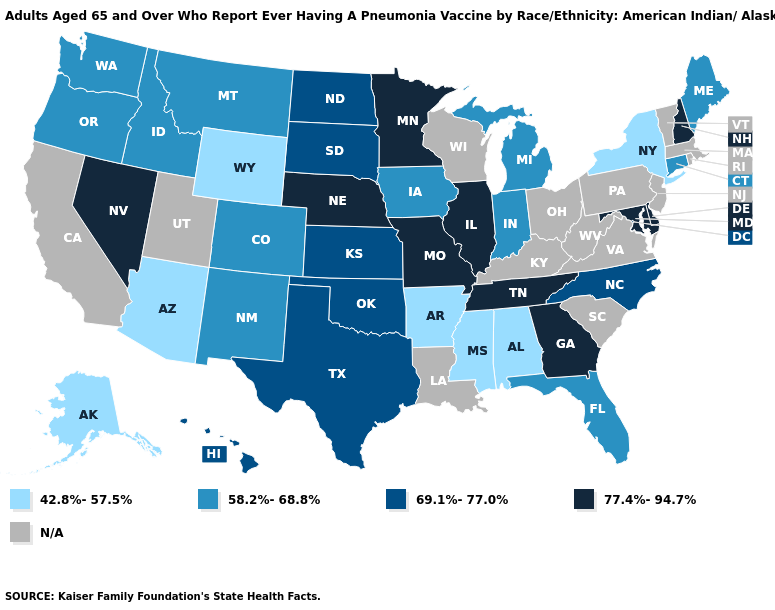Name the states that have a value in the range N/A?
Be succinct. California, Kentucky, Louisiana, Massachusetts, New Jersey, Ohio, Pennsylvania, Rhode Island, South Carolina, Utah, Vermont, Virginia, West Virginia, Wisconsin. What is the lowest value in the West?
Be succinct. 42.8%-57.5%. What is the value of California?
Quick response, please. N/A. Name the states that have a value in the range 42.8%-57.5%?
Quick response, please. Alabama, Alaska, Arizona, Arkansas, Mississippi, New York, Wyoming. Does Arizona have the lowest value in the USA?
Write a very short answer. Yes. Name the states that have a value in the range 77.4%-94.7%?
Quick response, please. Delaware, Georgia, Illinois, Maryland, Minnesota, Missouri, Nebraska, Nevada, New Hampshire, Tennessee. How many symbols are there in the legend?
Short answer required. 5. How many symbols are there in the legend?
Quick response, please. 5. What is the highest value in the USA?
Concise answer only. 77.4%-94.7%. What is the value of Vermont?
Answer briefly. N/A. Name the states that have a value in the range 42.8%-57.5%?
Keep it brief. Alabama, Alaska, Arizona, Arkansas, Mississippi, New York, Wyoming. What is the value of New Jersey?
Quick response, please. N/A. Does the first symbol in the legend represent the smallest category?
Short answer required. Yes. 